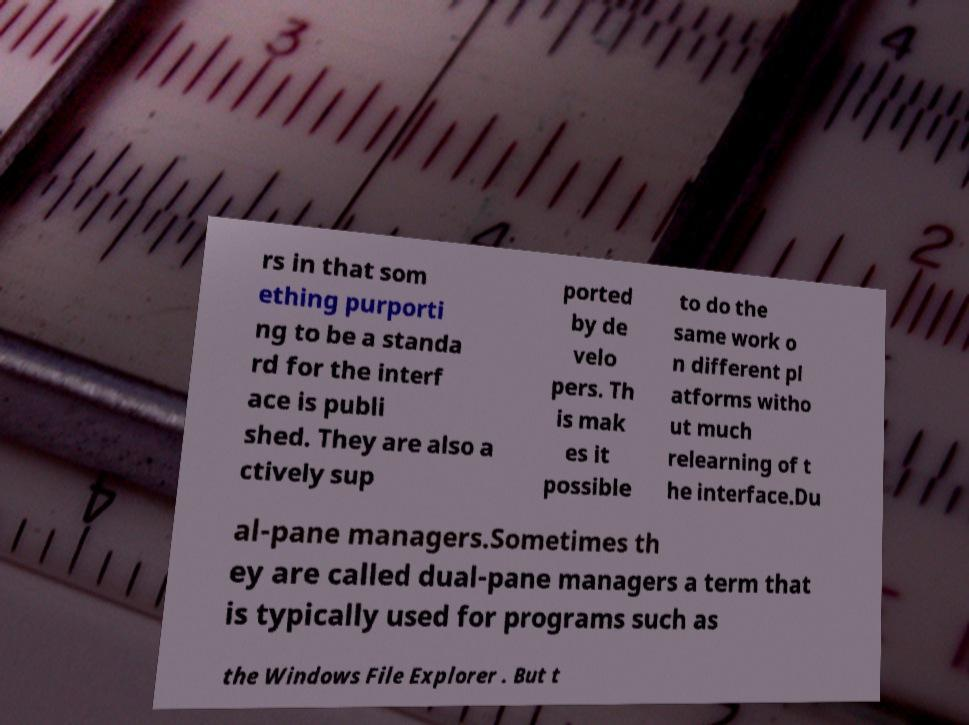Please identify and transcribe the text found in this image. rs in that som ething purporti ng to be a standa rd for the interf ace is publi shed. They are also a ctively sup ported by de velo pers. Th is mak es it possible to do the same work o n different pl atforms witho ut much relearning of t he interface.Du al-pane managers.Sometimes th ey are called dual-pane managers a term that is typically used for programs such as the Windows File Explorer . But t 